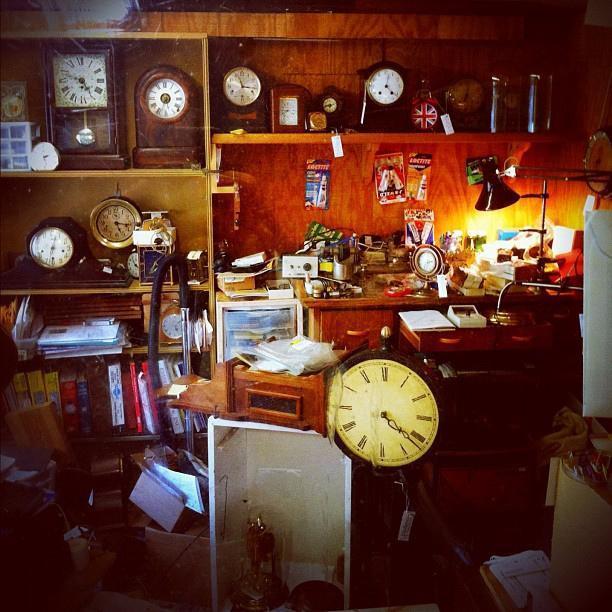How many clocks can be seen?
Give a very brief answer. 4. 